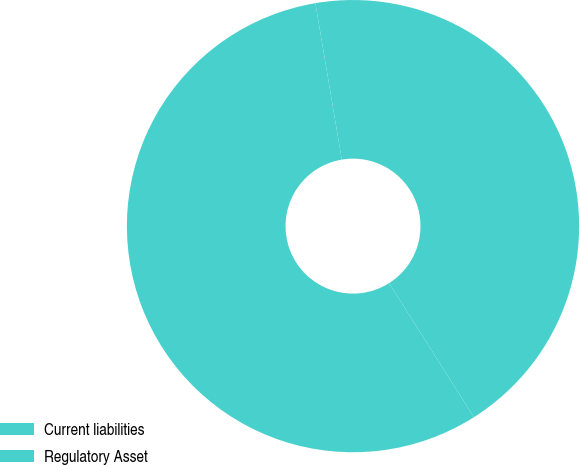Convert chart. <chart><loc_0><loc_0><loc_500><loc_500><pie_chart><fcel>Current liabilities<fcel>Regulatory Asset<nl><fcel>43.68%<fcel>56.32%<nl></chart> 